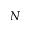Convert formula to latex. <formula><loc_0><loc_0><loc_500><loc_500>N</formula> 